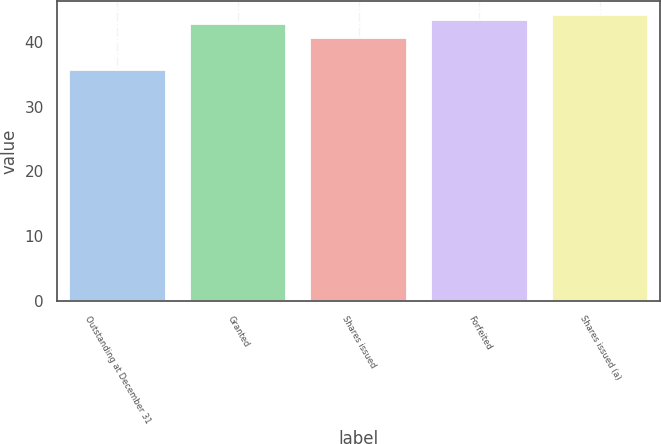Convert chart. <chart><loc_0><loc_0><loc_500><loc_500><bar_chart><fcel>Outstanding at December 31<fcel>Granted<fcel>Shares issued<fcel>Forfeited<fcel>Shares issued (a)<nl><fcel>35.67<fcel>42.75<fcel>40.68<fcel>43.44<fcel>44.13<nl></chart> 